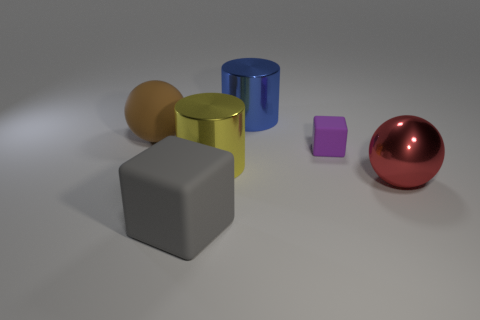Add 2 big red balls. How many objects exist? 8 Subtract all balls. How many objects are left? 4 Add 3 tiny brown matte objects. How many tiny brown matte objects exist? 3 Subtract 0 purple cylinders. How many objects are left? 6 Subtract all red spheres. Subtract all big blue metal cylinders. How many objects are left? 4 Add 6 big blue metallic cylinders. How many big blue metallic cylinders are left? 7 